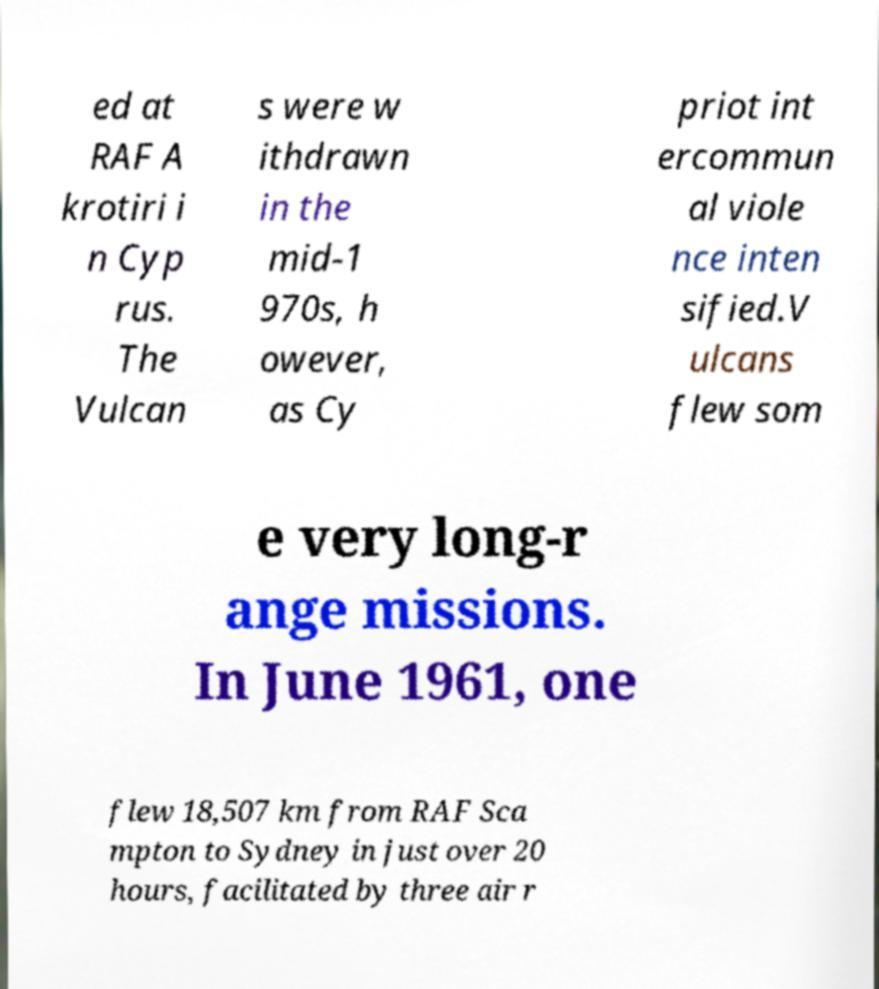I need the written content from this picture converted into text. Can you do that? ed at RAF A krotiri i n Cyp rus. The Vulcan s were w ithdrawn in the mid-1 970s, h owever, as Cy priot int ercommun al viole nce inten sified.V ulcans flew som e very long-r ange missions. In June 1961, one flew 18,507 km from RAF Sca mpton to Sydney in just over 20 hours, facilitated by three air r 